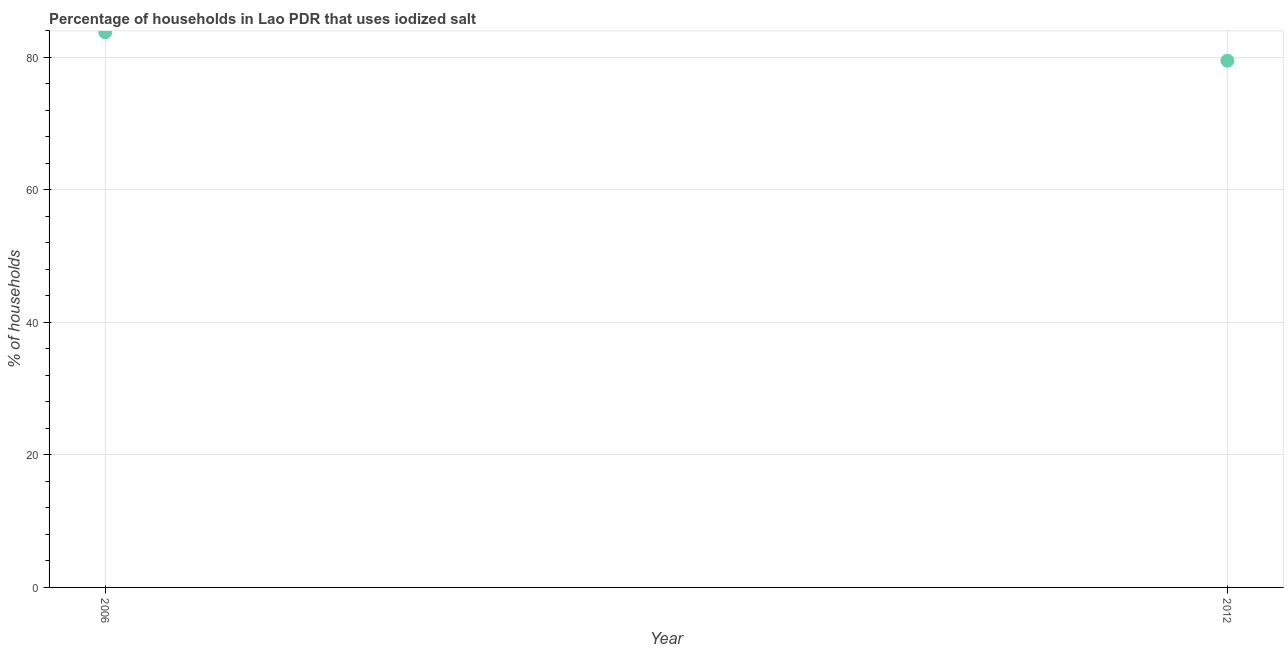What is the percentage of households where iodized salt is consumed in 2006?
Offer a very short reply. 83.8. Across all years, what is the maximum percentage of households where iodized salt is consumed?
Ensure brevity in your answer.  83.8. Across all years, what is the minimum percentage of households where iodized salt is consumed?
Your answer should be very brief. 79.5. In which year was the percentage of households where iodized salt is consumed minimum?
Your answer should be compact. 2012. What is the sum of the percentage of households where iodized salt is consumed?
Your answer should be very brief. 163.3. What is the difference between the percentage of households where iodized salt is consumed in 2006 and 2012?
Make the answer very short. 4.3. What is the average percentage of households where iodized salt is consumed per year?
Give a very brief answer. 81.65. What is the median percentage of households where iodized salt is consumed?
Your answer should be very brief. 81.65. Do a majority of the years between 2006 and 2012 (inclusive) have percentage of households where iodized salt is consumed greater than 76 %?
Give a very brief answer. Yes. What is the ratio of the percentage of households where iodized salt is consumed in 2006 to that in 2012?
Offer a very short reply. 1.05. Is the percentage of households where iodized salt is consumed in 2006 less than that in 2012?
Provide a short and direct response. No. Does the graph contain any zero values?
Provide a short and direct response. No. What is the title of the graph?
Provide a succinct answer. Percentage of households in Lao PDR that uses iodized salt. What is the label or title of the X-axis?
Keep it short and to the point. Year. What is the label or title of the Y-axis?
Make the answer very short. % of households. What is the % of households in 2006?
Your response must be concise. 83.8. What is the % of households in 2012?
Your answer should be compact. 79.5. What is the ratio of the % of households in 2006 to that in 2012?
Give a very brief answer. 1.05. 